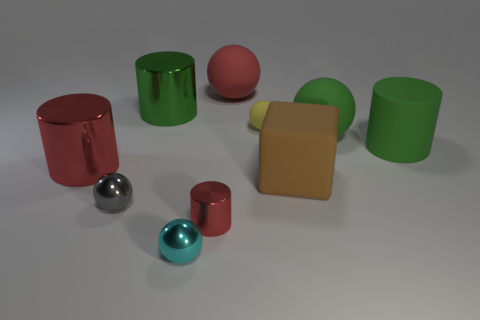Subtract all red cylinders. How many were subtracted if there are1red cylinders left? 1 Subtract all yellow spheres. How many spheres are left? 4 Subtract all cyan spheres. How many spheres are left? 4 Subtract all brown balls. Subtract all cyan cylinders. How many balls are left? 5 Subtract all cylinders. How many objects are left? 6 Subtract 1 green balls. How many objects are left? 9 Subtract all small yellow metal things. Subtract all gray metallic spheres. How many objects are left? 9 Add 8 matte cylinders. How many matte cylinders are left? 9 Add 7 green cylinders. How many green cylinders exist? 9 